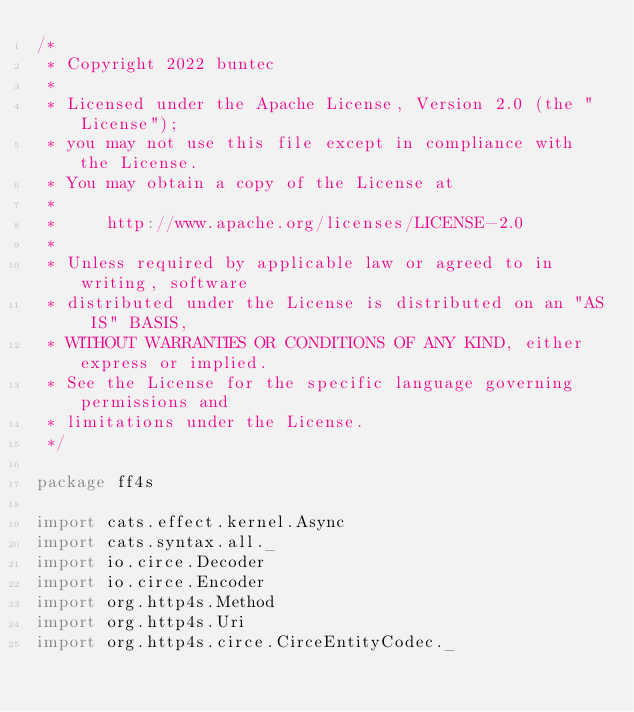Convert code to text. <code><loc_0><loc_0><loc_500><loc_500><_Scala_>/*
 * Copyright 2022 buntec
 *
 * Licensed under the Apache License, Version 2.0 (the "License");
 * you may not use this file except in compliance with the License.
 * You may obtain a copy of the License at
 *
 *     http://www.apache.org/licenses/LICENSE-2.0
 *
 * Unless required by applicable law or agreed to in writing, software
 * distributed under the License is distributed on an "AS IS" BASIS,
 * WITHOUT WARRANTIES OR CONDITIONS OF ANY KIND, either express or implied.
 * See the License for the specific language governing permissions and
 * limitations under the License.
 */

package ff4s

import cats.effect.kernel.Async
import cats.syntax.all._
import io.circe.Decoder
import io.circe.Encoder
import org.http4s.Method
import org.http4s.Uri
import org.http4s.circe.CirceEntityCodec._</code> 